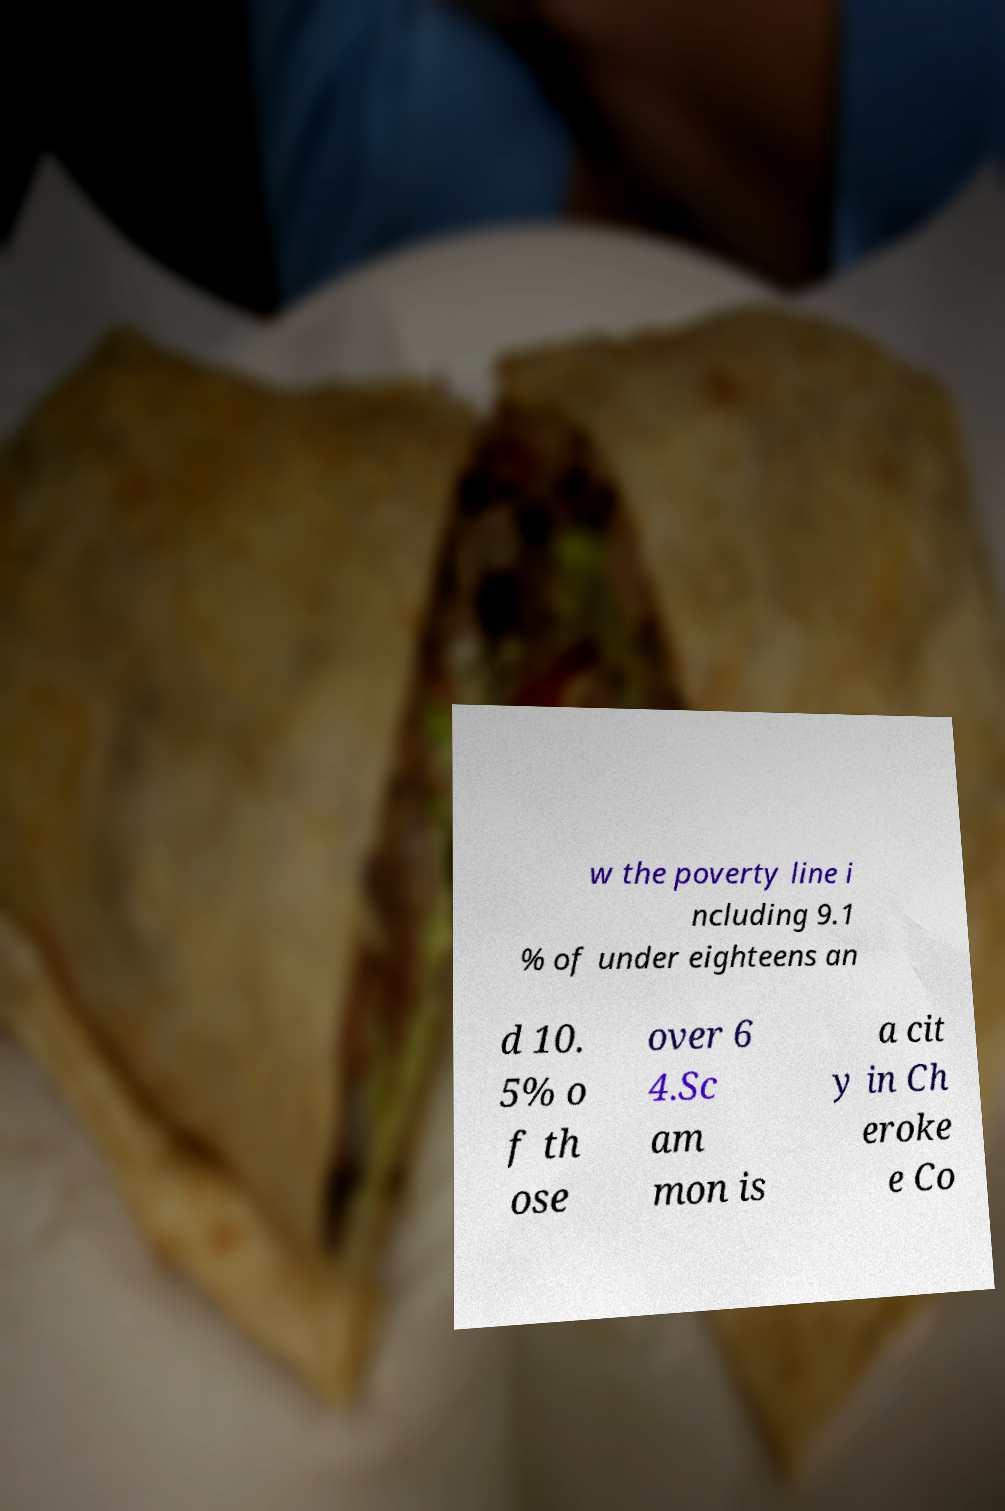Can you accurately transcribe the text from the provided image for me? w the poverty line i ncluding 9.1 % of under eighteens an d 10. 5% o f th ose over 6 4.Sc am mon is a cit y in Ch eroke e Co 